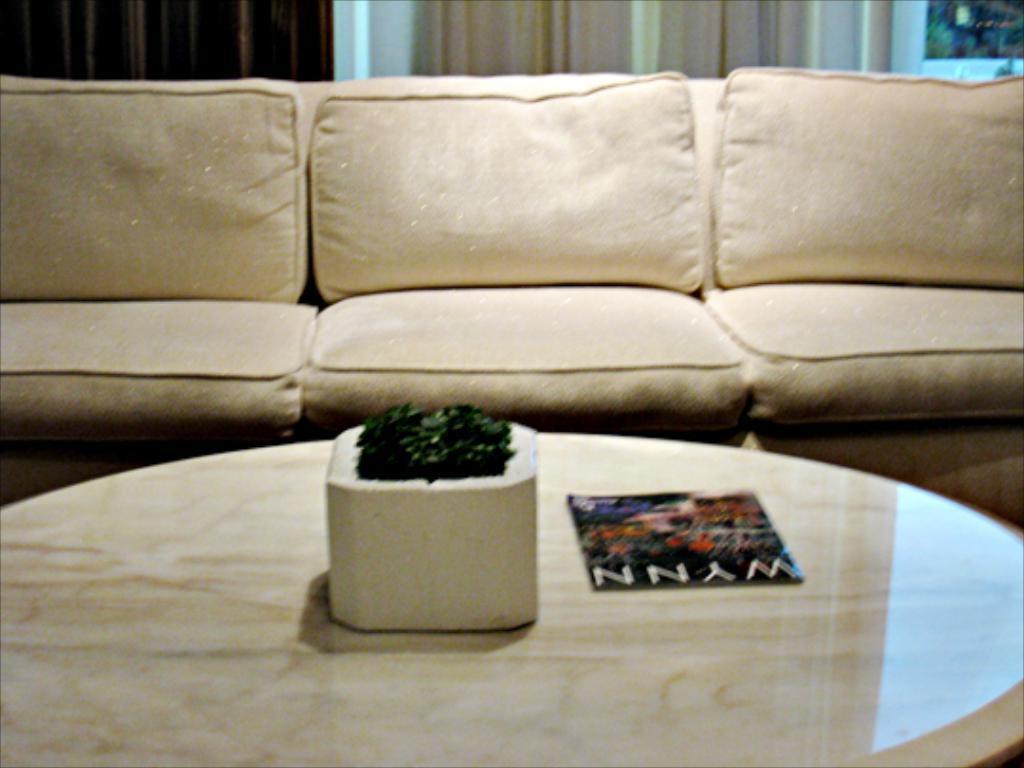Please provide a concise description of this image. In this image in front there is a table. On top of the table there is a flower pot and a magazine. Behind the table there is a sofa. On the backside there are curtains. 